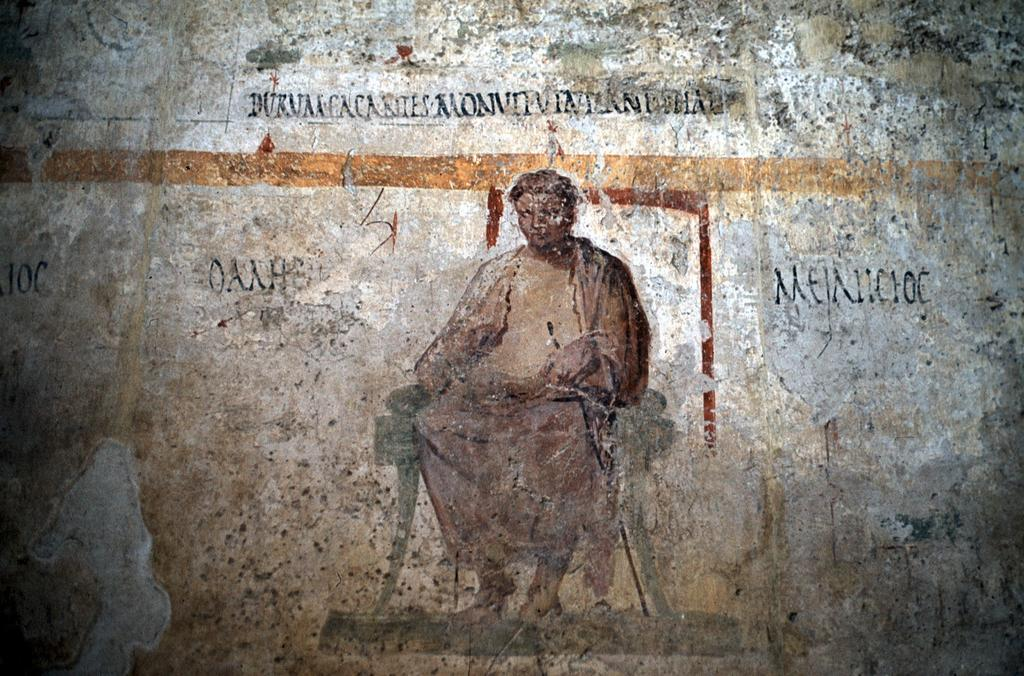What is hanging on the wall in the image? There is a painting on the wall in the image. Can you describe the painting in any way? Unfortunately, the provided facts do not give any information about the appearance or content of the painting. What might the painting be depicting or representing? Again, the provided facts do not give any information about the subject matter of the painting. What type of thrill can be experienced by reading the guide in the image? There is no guide present in the image, and therefore no such experience can be had. 